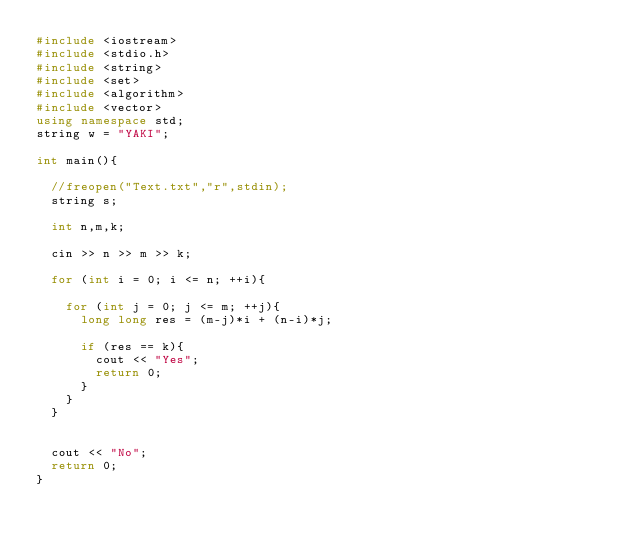<code> <loc_0><loc_0><loc_500><loc_500><_C++_>#include <iostream>
#include <stdio.h>
#include <string>
#include <set>
#include <algorithm>
#include <vector>
using namespace std;
string w = "YAKI";

int main(){

	//freopen("Text.txt","r",stdin);
	string s;

	int n,m,k;

	cin >> n >> m >> k;

	for (int i = 0; i <= n; ++i){

		for (int j = 0; j <= m; ++j){
			long long res = (m-j)*i + (n-i)*j;

			if (res == k){
				cout << "Yes";
				return 0;
			}
		}
	}


	cout << "No";
	return 0;
}</code> 